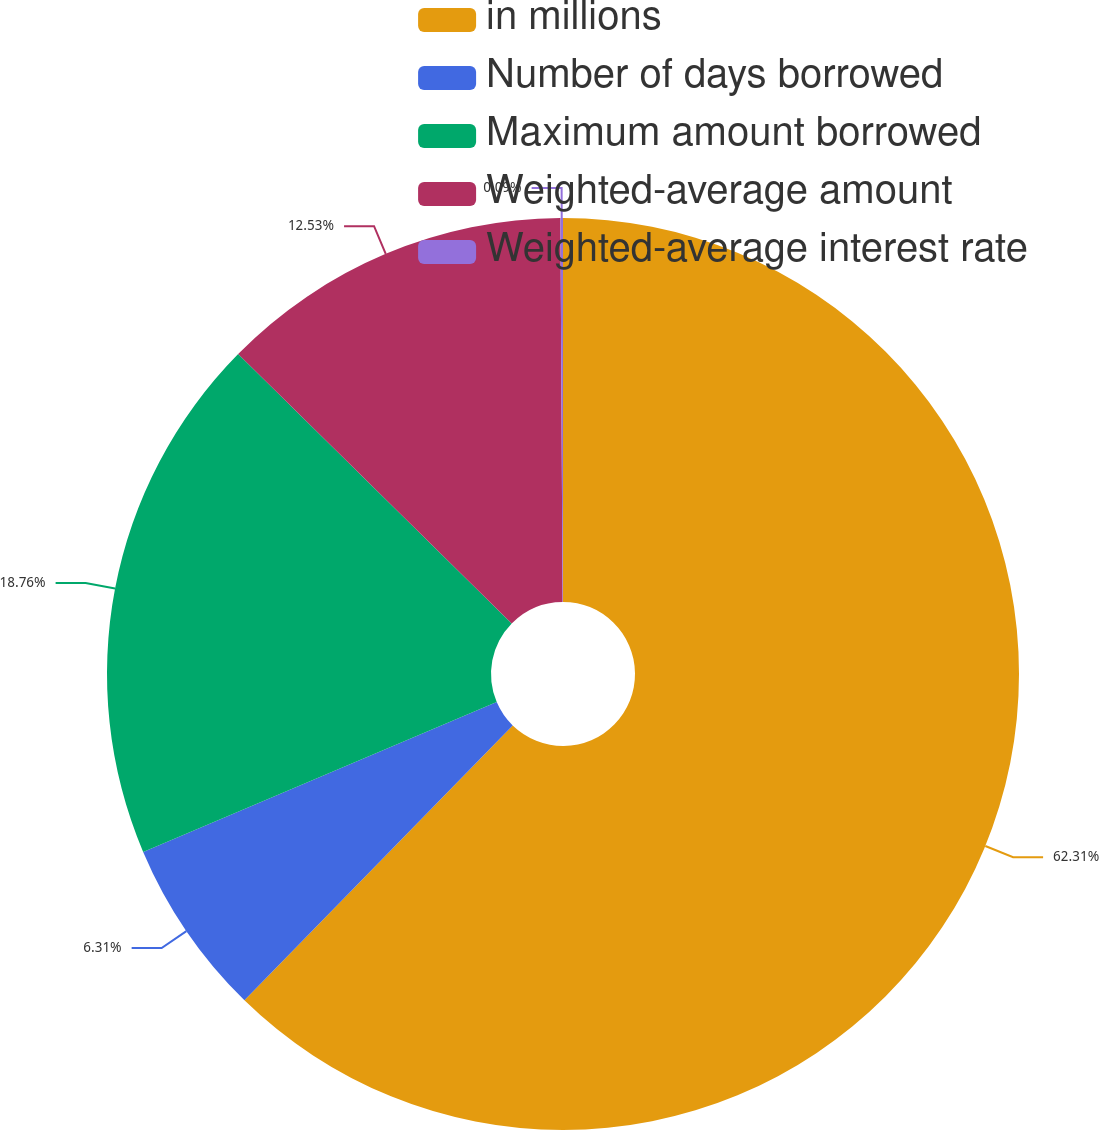Convert chart to OTSL. <chart><loc_0><loc_0><loc_500><loc_500><pie_chart><fcel>in millions<fcel>Number of days borrowed<fcel>Maximum amount borrowed<fcel>Weighted-average amount<fcel>Weighted-average interest rate<nl><fcel>62.31%<fcel>6.31%<fcel>18.76%<fcel>12.53%<fcel>0.09%<nl></chart> 